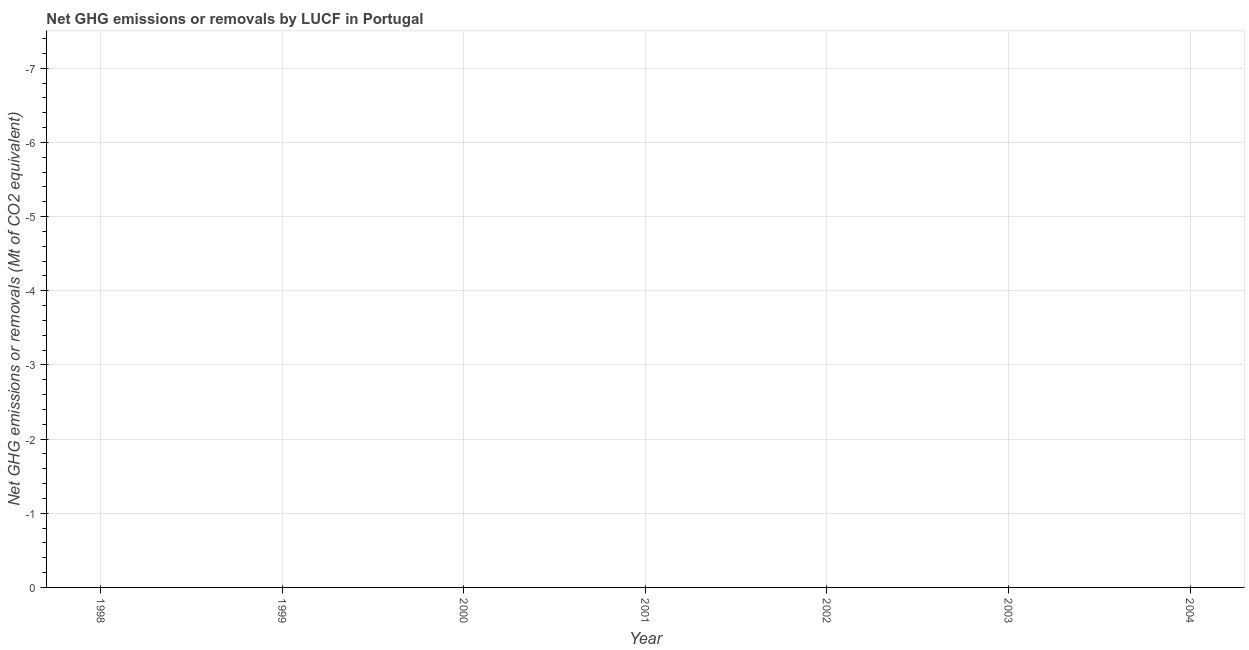Across all years, what is the minimum ghg net emissions or removals?
Make the answer very short. 0. What is the average ghg net emissions or removals per year?
Keep it short and to the point. 0. What is the median ghg net emissions or removals?
Make the answer very short. 0. In how many years, is the ghg net emissions or removals greater than the average ghg net emissions or removals taken over all years?
Provide a short and direct response. 0. How many dotlines are there?
Offer a very short reply. 0. How many years are there in the graph?
Offer a terse response. 7. What is the title of the graph?
Give a very brief answer. Net GHG emissions or removals by LUCF in Portugal. What is the label or title of the X-axis?
Your answer should be very brief. Year. What is the label or title of the Y-axis?
Your response must be concise. Net GHG emissions or removals (Mt of CO2 equivalent). What is the Net GHG emissions or removals (Mt of CO2 equivalent) in 1998?
Make the answer very short. 0. What is the Net GHG emissions or removals (Mt of CO2 equivalent) in 2002?
Provide a succinct answer. 0. 